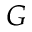<formula> <loc_0><loc_0><loc_500><loc_500>G</formula> 